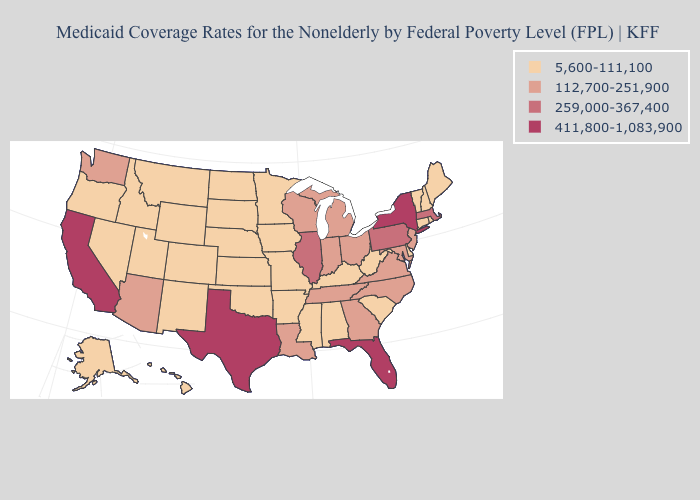How many symbols are there in the legend?
Short answer required. 4. Which states have the lowest value in the South?
Quick response, please. Alabama, Arkansas, Delaware, Kentucky, Mississippi, Oklahoma, South Carolina, West Virginia. Does Washington have a higher value than South Dakota?
Keep it brief. Yes. What is the highest value in states that border Nevada?
Concise answer only. 411,800-1,083,900. What is the value of North Dakota?
Short answer required. 5,600-111,100. Name the states that have a value in the range 112,700-251,900?
Be succinct. Arizona, Georgia, Indiana, Louisiana, Maryland, Michigan, New Jersey, North Carolina, Ohio, Tennessee, Virginia, Washington, Wisconsin. Which states have the lowest value in the USA?
Short answer required. Alabama, Alaska, Arkansas, Colorado, Connecticut, Delaware, Hawaii, Idaho, Iowa, Kansas, Kentucky, Maine, Minnesota, Mississippi, Missouri, Montana, Nebraska, Nevada, New Hampshire, New Mexico, North Dakota, Oklahoma, Oregon, Rhode Island, South Carolina, South Dakota, Utah, Vermont, West Virginia, Wyoming. What is the value of Virginia?
Give a very brief answer. 112,700-251,900. Does North Carolina have the highest value in the South?
Write a very short answer. No. Name the states that have a value in the range 259,000-367,400?
Be succinct. Illinois, Massachusetts, Pennsylvania. Does Alabama have a lower value than Vermont?
Write a very short answer. No. Among the states that border West Virginia , which have the lowest value?
Keep it brief. Kentucky. Which states have the lowest value in the MidWest?
Answer briefly. Iowa, Kansas, Minnesota, Missouri, Nebraska, North Dakota, South Dakota. What is the value of Montana?
Give a very brief answer. 5,600-111,100. Name the states that have a value in the range 5,600-111,100?
Give a very brief answer. Alabama, Alaska, Arkansas, Colorado, Connecticut, Delaware, Hawaii, Idaho, Iowa, Kansas, Kentucky, Maine, Minnesota, Mississippi, Missouri, Montana, Nebraska, Nevada, New Hampshire, New Mexico, North Dakota, Oklahoma, Oregon, Rhode Island, South Carolina, South Dakota, Utah, Vermont, West Virginia, Wyoming. 